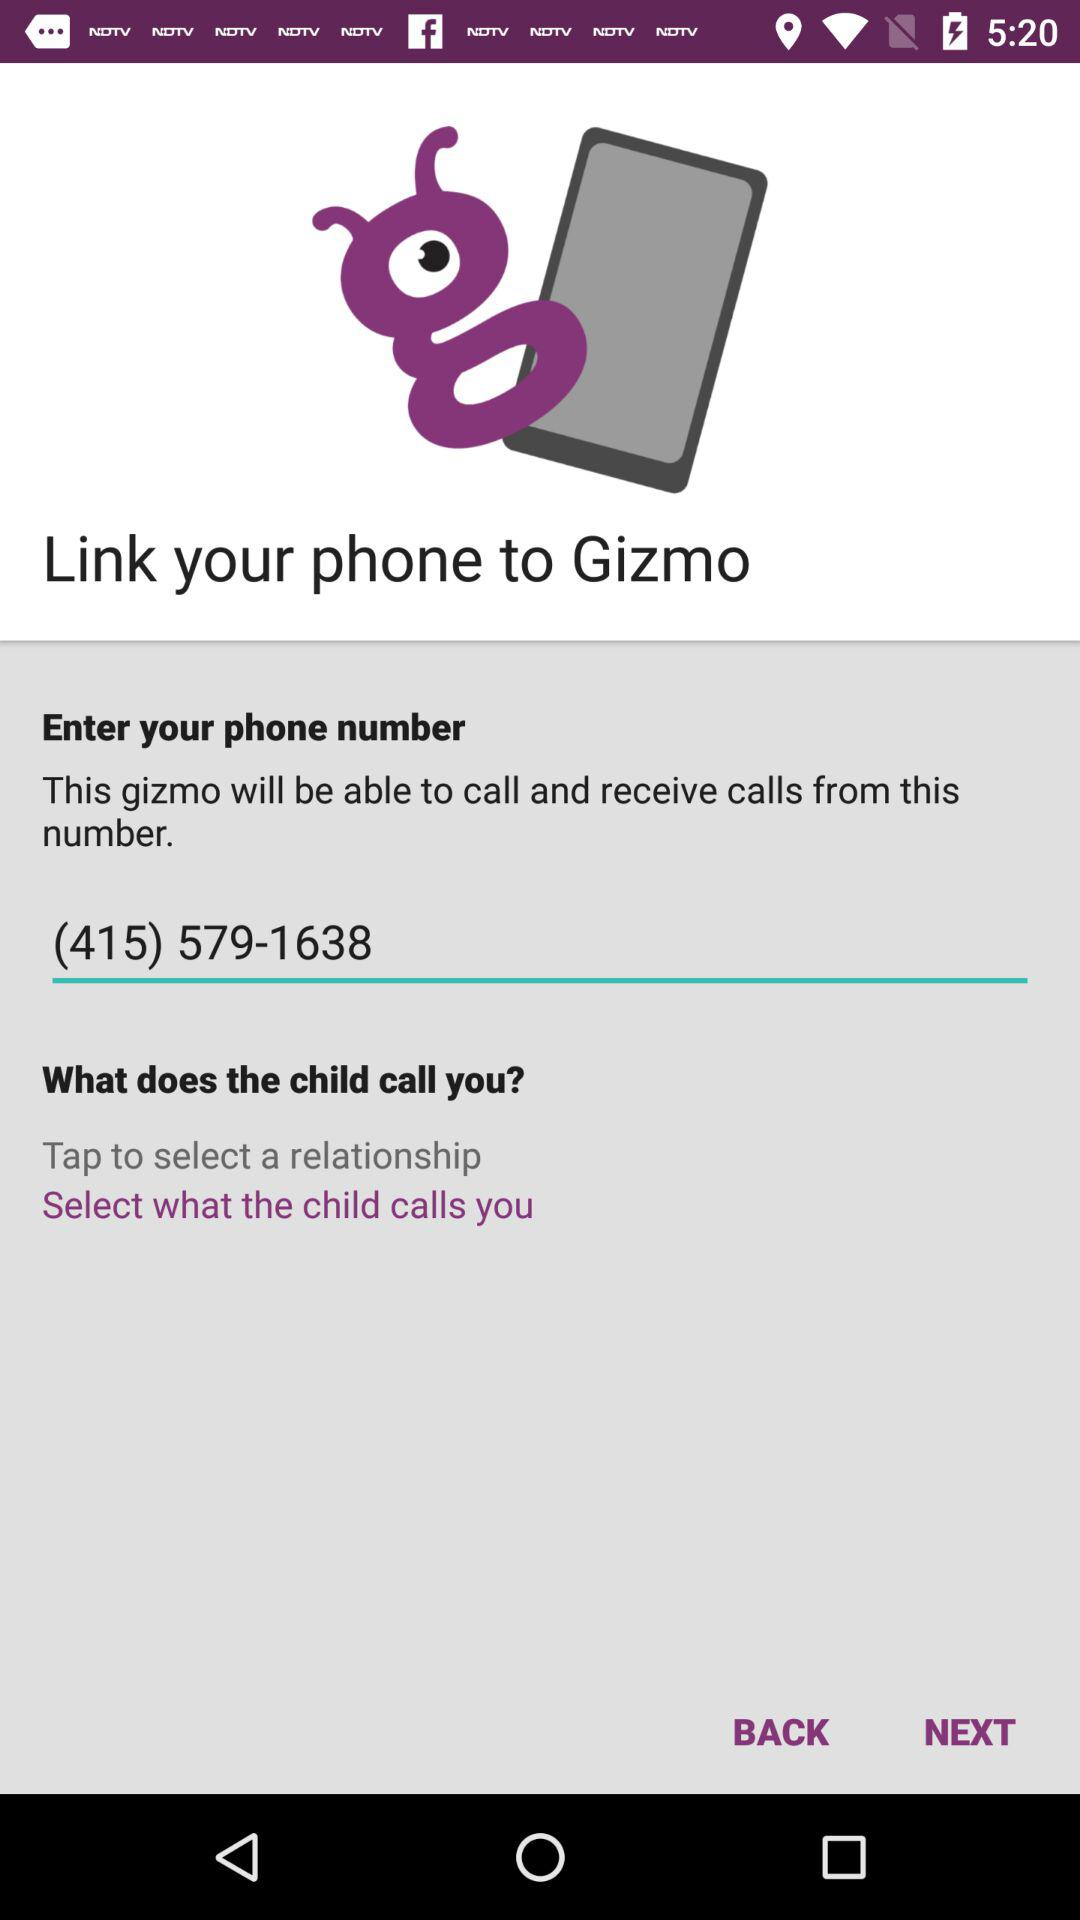What is the phone number? The phone number is (415) 579-1638. 